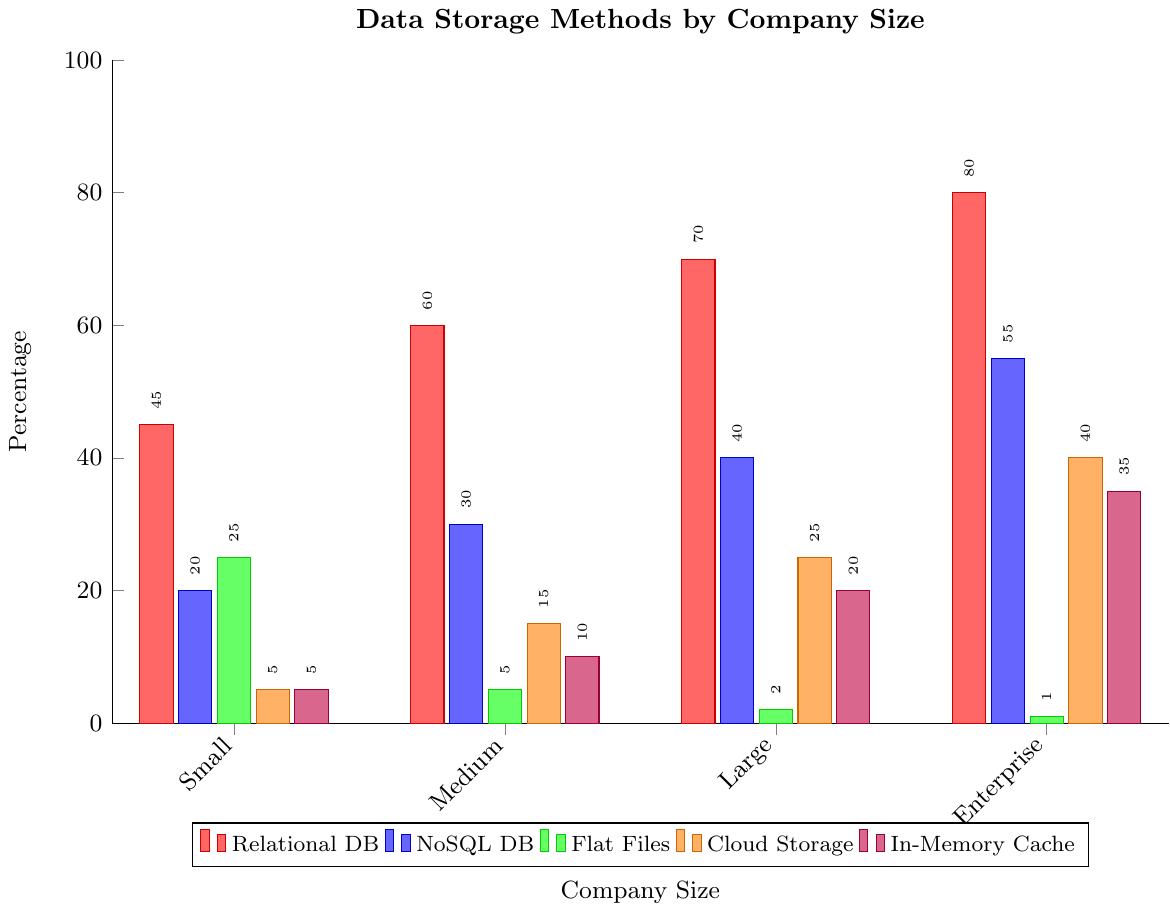What is the most common data storage method for Enterprise companies? The bar representing Relational DB for Enterprise companies is the tallest bar, indicating it is the most common storage method.
Answer: Relational DB Which company size uses Flat Files the least, and what percentage do they use it? By comparing the heights of the Flat Files bars, it's clear that Enterprise companies use it the least, with a very short bar indicating 1%.
Answer: Enterprise, 1% What is the total percentage usage of Cloud Storage across all company sizes? Sum the values of Cloud Storage for all company sizes: 5 (Small) + 15 (Medium) + 25 (Large) + 40 (Enterprise) = 85%
Answer: 85% Compare the usage of NoSQL DB between Large and Enterprise companies. The bar for NoSQL DB in Large companies reaches 40%, whereas the bar for Enterprise companies reaches 55%.
Answer: Large companies: 40%, Enterprise companies: 55% How much more does Enterprise companies use In-Memory Cache compared to Medium companies? The height of the In-Memory Cache bar for Enterprise companies is 35%, and for Medium companies, it is 10%. The difference is 35% - 10% = 25%.
Answer: 25% Which data storage method is equally used by Small companies, and what is their usage percentage? Both Cloud Storage and In-Memory Cache have bars of equal height at 5% for Small companies.
Answer: Cloud Storage and In-Memory Cache, 5% What is the average usage of Relational DB across all company sizes? Sum the Relational DB percentages and divide by the number of company sizes: (45 + 60 + 70 + 80) / 4 = 255 / 4 = 63.75%
Answer: 63.75% Which company size uses Cloud Storage more than Flat Files? Medium, Large, and Enterprise companies all have taller bars for Cloud Storage than Flat Files, indicating higher usage of Cloud Storage.
Answer: Medium, Large, Enterprise Is the percentage of Relational DB usage greater for Large or Small companies? By how much? The Relational DB bar for Large companies is at 70%, while for Small companies it is at 45%. The difference is 70% - 45% = 25%.
Answer: Large, 25% What is the combined usage percentage of Flat Files and NoSQL DB for Small companies? Add the Flat Files percentage and NoSQL DB percentage: 25% (Flat Files) + 20% (NoSQL DB) = 45%.
Answer: 45% 